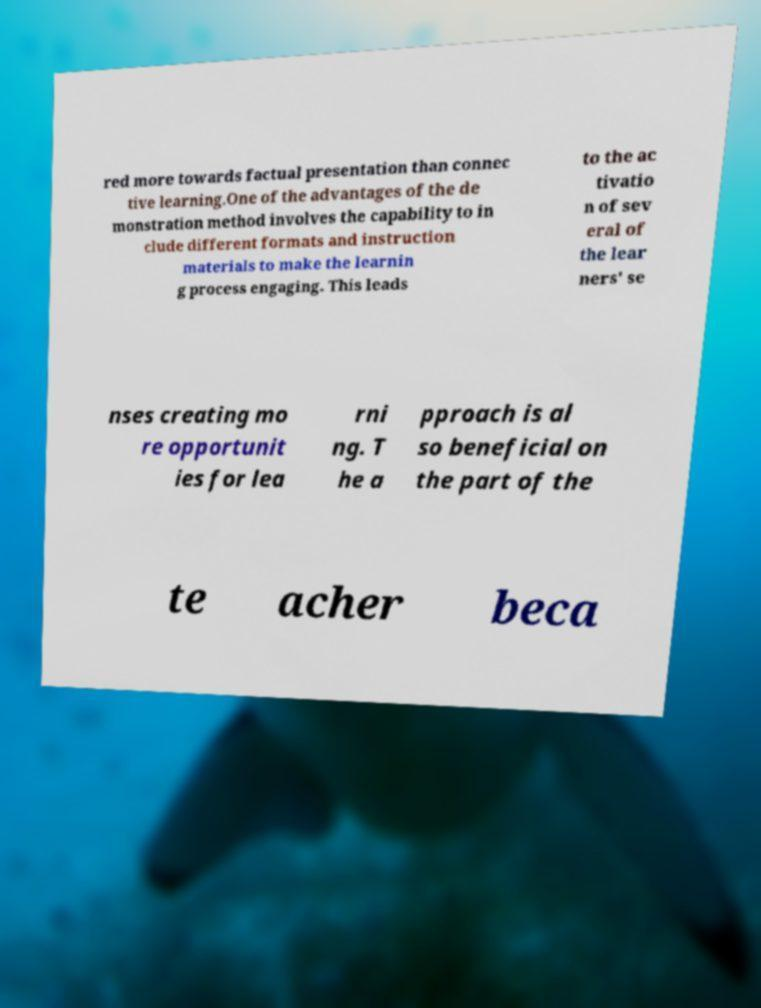Can you accurately transcribe the text from the provided image for me? red more towards factual presentation than connec tive learning.One of the advantages of the de monstration method involves the capability to in clude different formats and instruction materials to make the learnin g process engaging. This leads to the ac tivatio n of sev eral of the lear ners' se nses creating mo re opportunit ies for lea rni ng. T he a pproach is al so beneficial on the part of the te acher beca 